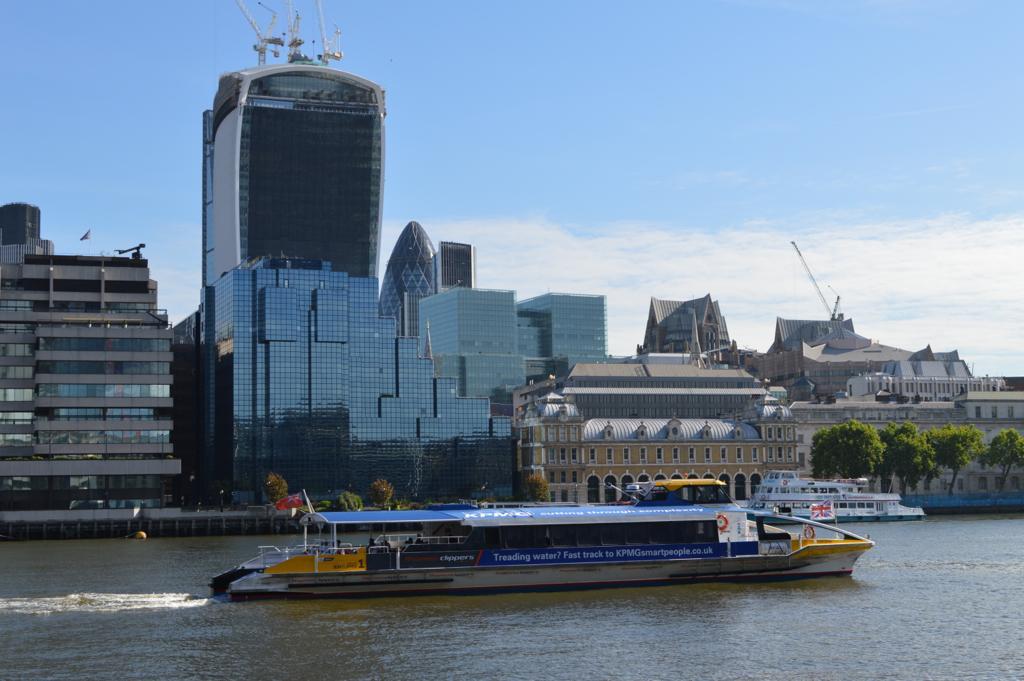How would you summarize this image in a sentence or two? There is a ship on the water and there are buildings and trees in the background. 